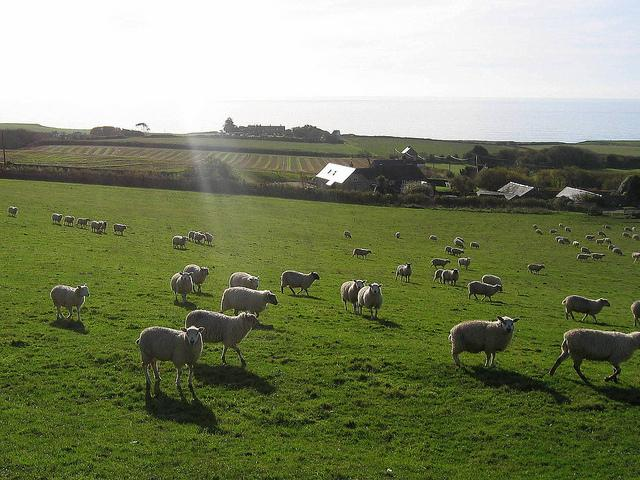What type of worker would be found here? farmer 